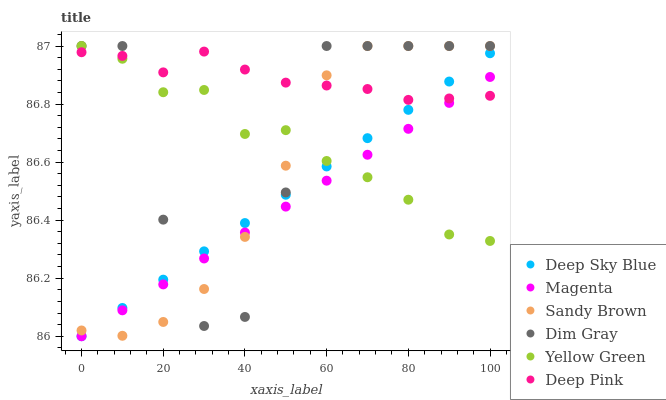Does Magenta have the minimum area under the curve?
Answer yes or no. Yes. Does Deep Pink have the maximum area under the curve?
Answer yes or no. Yes. Does Yellow Green have the minimum area under the curve?
Answer yes or no. No. Does Yellow Green have the maximum area under the curve?
Answer yes or no. No. Is Magenta the smoothest?
Answer yes or no. Yes. Is Dim Gray the roughest?
Answer yes or no. Yes. Is Yellow Green the smoothest?
Answer yes or no. No. Is Yellow Green the roughest?
Answer yes or no. No. Does Deep Sky Blue have the lowest value?
Answer yes or no. Yes. Does Yellow Green have the lowest value?
Answer yes or no. No. Does Sandy Brown have the highest value?
Answer yes or no. Yes. Does Deep Pink have the highest value?
Answer yes or no. No. Does Yellow Green intersect Deep Sky Blue?
Answer yes or no. Yes. Is Yellow Green less than Deep Sky Blue?
Answer yes or no. No. Is Yellow Green greater than Deep Sky Blue?
Answer yes or no. No. 